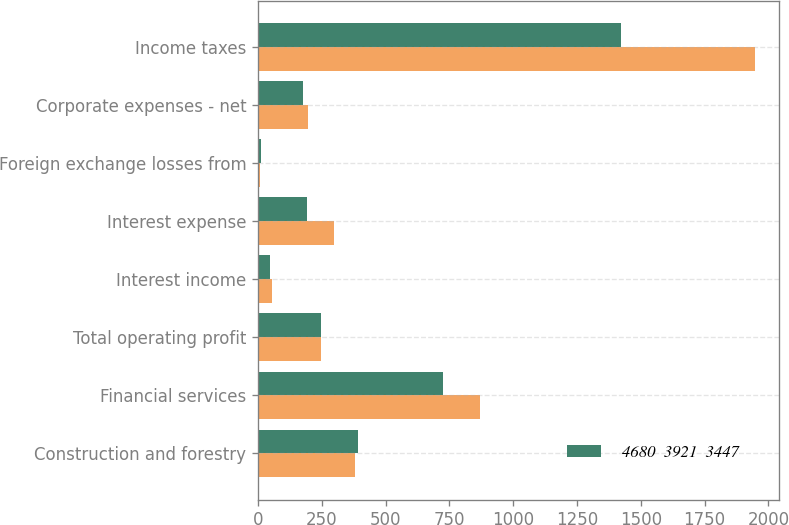Convert chart. <chart><loc_0><loc_0><loc_500><loc_500><stacked_bar_chart><ecel><fcel>Construction and forestry<fcel>Financial services<fcel>Total operating profit<fcel>Interest income<fcel>Interest expense<fcel>Foreign exchange losses from<fcel>Corporate expenses - net<fcel>Income taxes<nl><fcel>nan<fcel>378<fcel>870<fcel>247<fcel>55<fcel>297<fcel>8<fcel>197<fcel>1946<nl><fcel>4680  3921  3447<fcel>392<fcel>725<fcel>247<fcel>47<fcel>191<fcel>11<fcel>177<fcel>1424<nl></chart> 